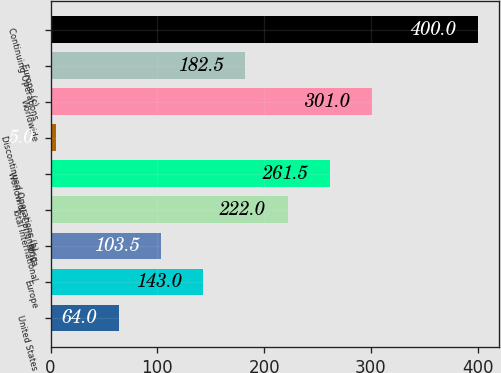Convert chart. <chart><loc_0><loc_0><loc_500><loc_500><bar_chart><fcel>United States<fcel>Europe<fcel>Africa<fcel>Total International<fcel>Worldwide Continuing<fcel>Discontinued Operations (b)<fcel>Worldwide<fcel>Europe (c)<fcel>Continuing Operations<nl><fcel>64<fcel>143<fcel>103.5<fcel>222<fcel>261.5<fcel>5<fcel>301<fcel>182.5<fcel>400<nl></chart> 